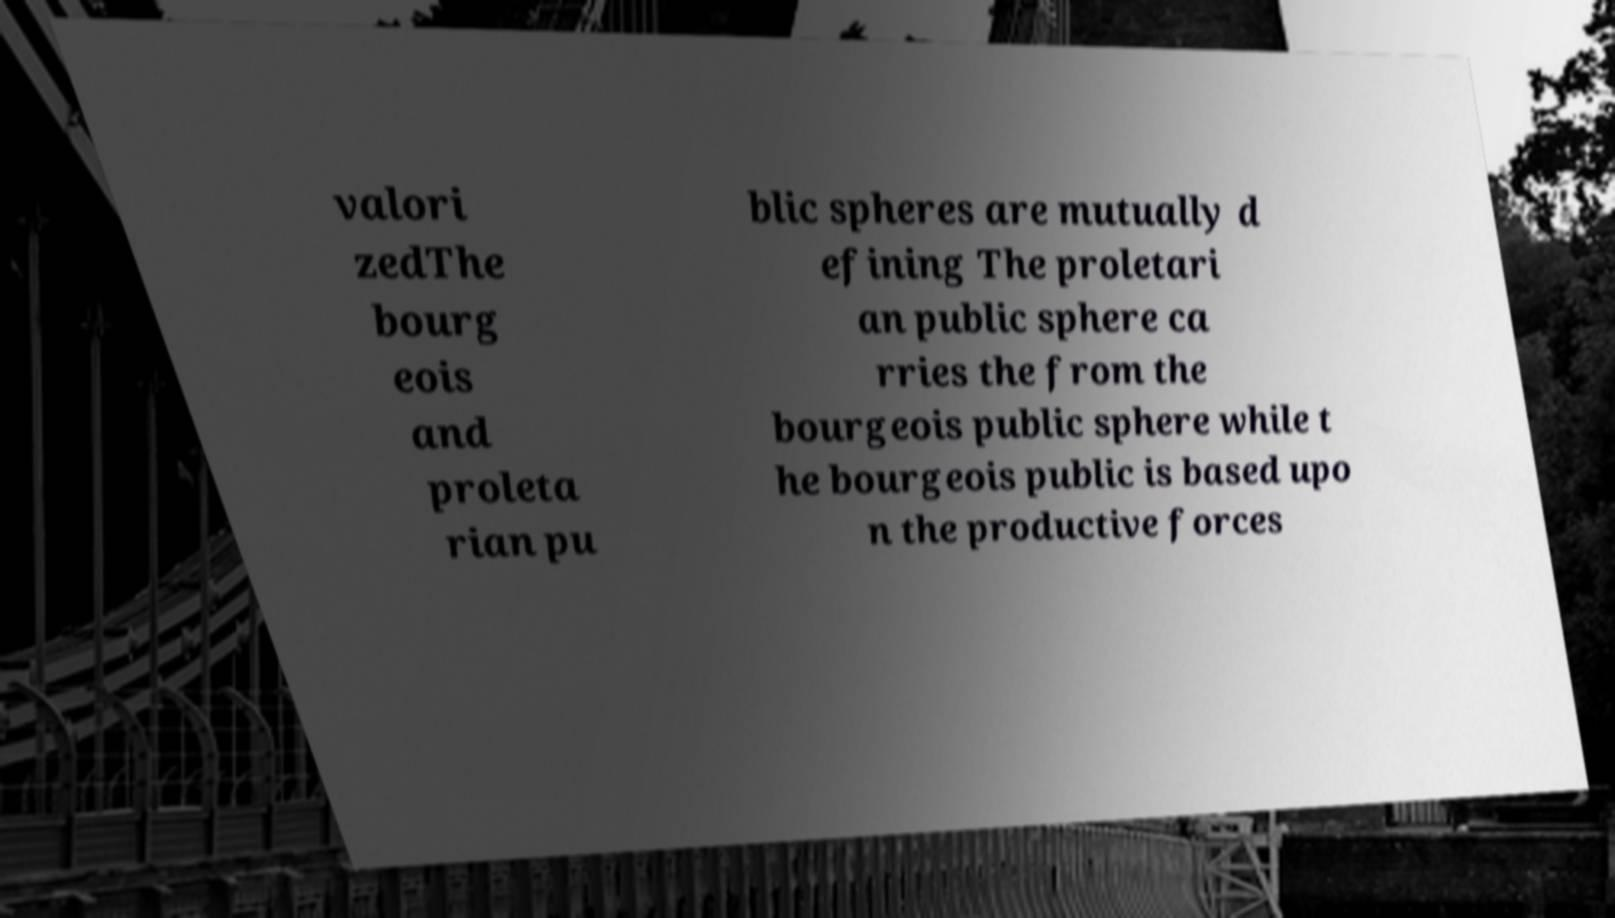Can you read and provide the text displayed in the image?This photo seems to have some interesting text. Can you extract and type it out for me? valori zedThe bourg eois and proleta rian pu blic spheres are mutually d efining The proletari an public sphere ca rries the from the bourgeois public sphere while t he bourgeois public is based upo n the productive forces 